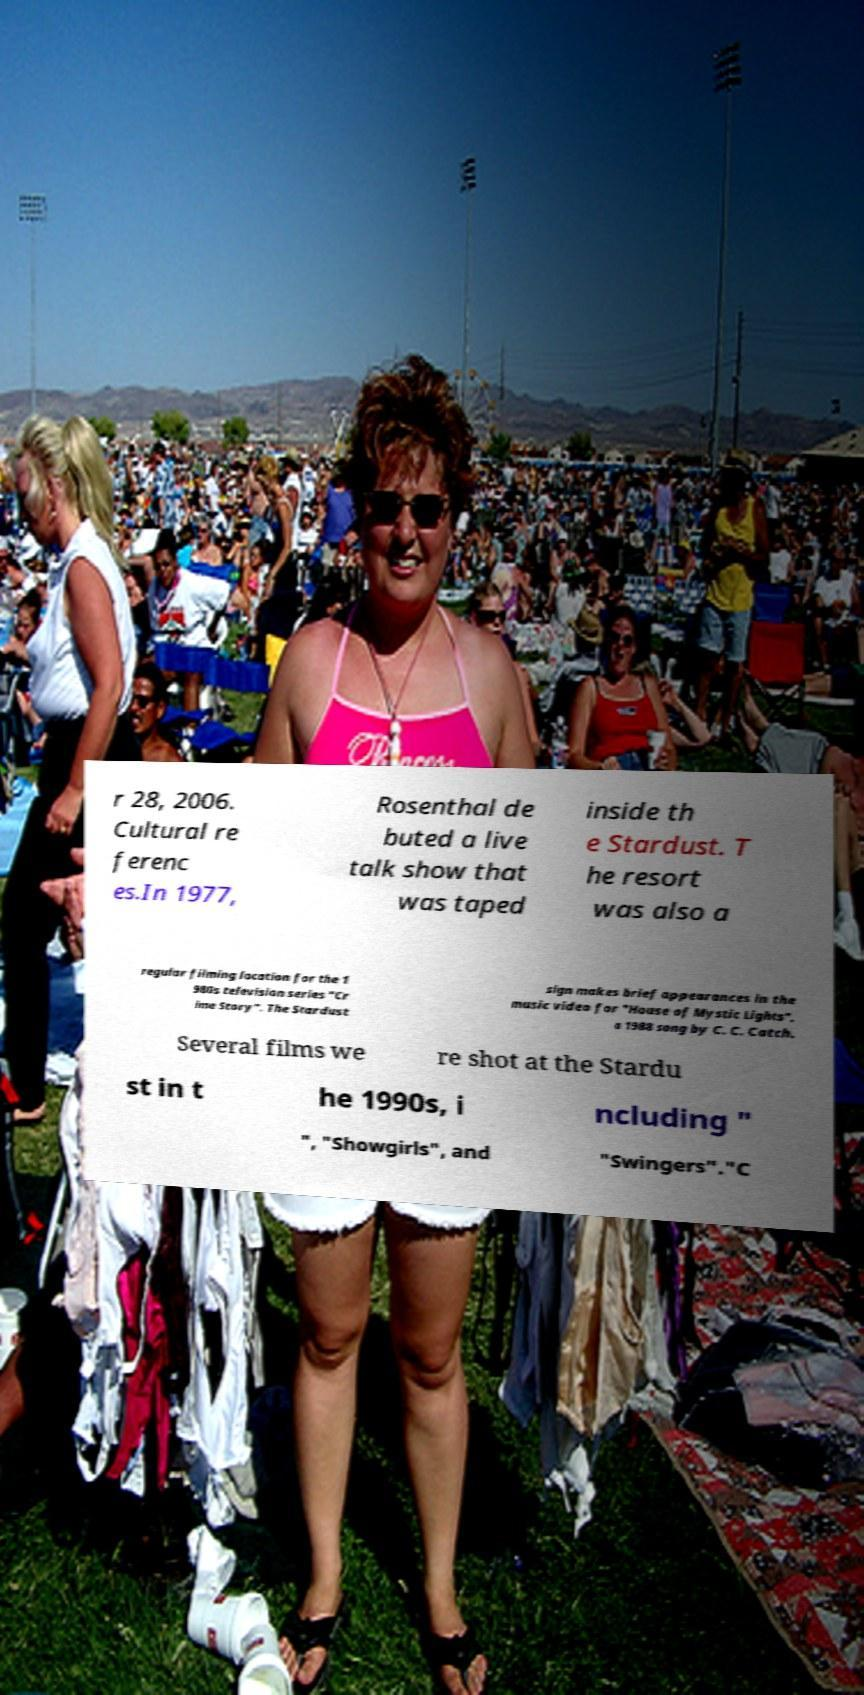Could you extract and type out the text from this image? r 28, 2006. Cultural re ferenc es.In 1977, Rosenthal de buted a live talk show that was taped inside th e Stardust. T he resort was also a regular filming location for the 1 980s television series "Cr ime Story". The Stardust sign makes brief appearances in the music video for "House of Mystic Lights", a 1988 song by C. C. Catch. Several films we re shot at the Stardu st in t he 1990s, i ncluding " ", "Showgirls", and "Swingers"."C 